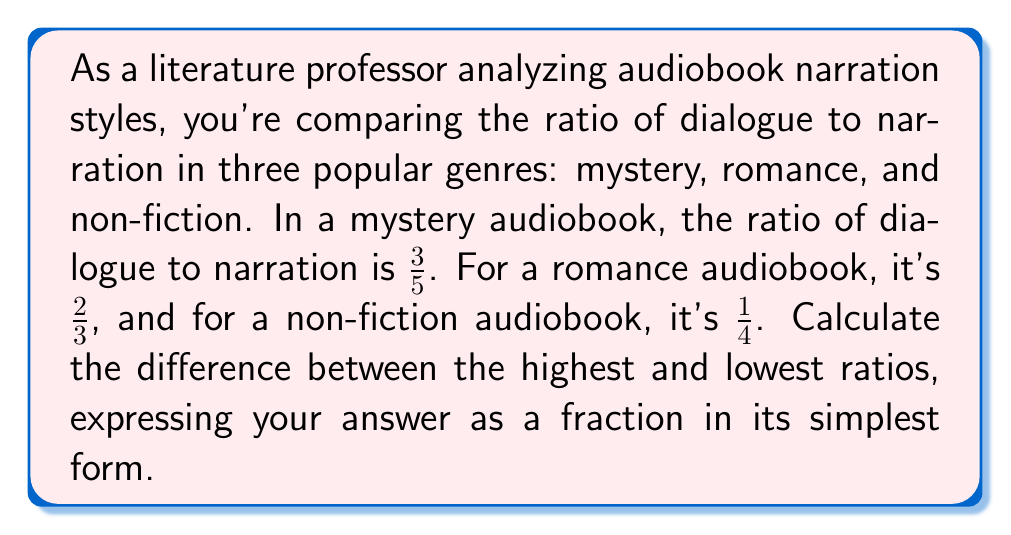Provide a solution to this math problem. To solve this problem, we need to follow these steps:

1. Convert all fractions to a common denominator for easy comparison.
2. Identify the highest and lowest ratios.
3. Subtract the lowest from the highest.
4. Simplify the resulting fraction if possible.

Step 1: Converting to a common denominator
Let's use 60 as the common denominator:

Mystery: $\frac{3}{5} = \frac{3 \times 12}{5 \times 12} = \frac{36}{60}$
Romance: $\frac{2}{3} = \frac{2 \times 20}{3 \times 20} = \frac{40}{60}$
Non-fiction: $\frac{1}{4} = \frac{1 \times 15}{4 \times 15} = \frac{15}{60}$

Step 2: Identifying highest and lowest ratios
Highest: Romance at $\frac{40}{60}$
Lowest: Non-fiction at $\frac{15}{60}$

Step 3: Subtracting the lowest from the highest
$$\frac{40}{60} - \frac{15}{60} = \frac{25}{60}$$

Step 4: Simplifying the fraction
We can divide both the numerator and denominator by their greatest common divisor (GCD). The GCD of 25 and 60 is 5.

$$\frac{25 \div 5}{60 \div 5} = \frac{5}{12}$$

Therefore, the difference between the highest and lowest ratios is $\frac{5}{12}$.
Answer: $\frac{5}{12}$ 